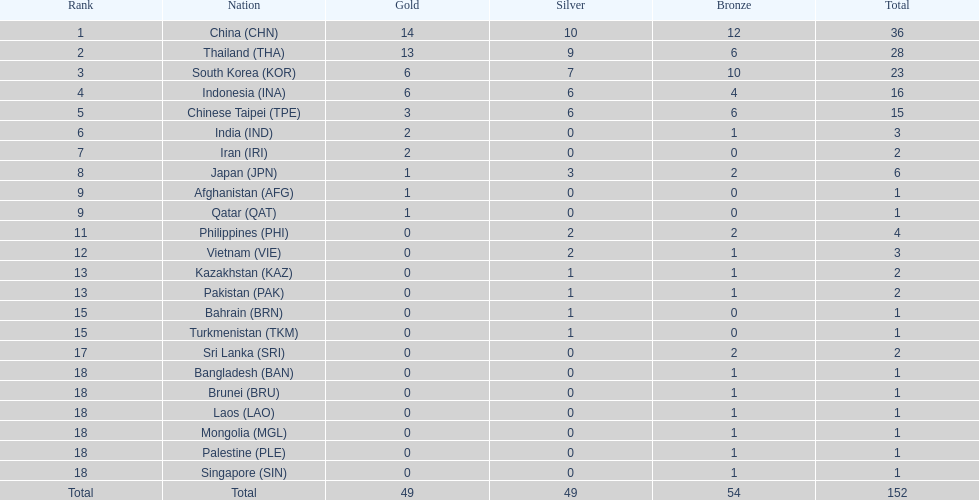How many more medals did india earn compared to pakistan? 1. 